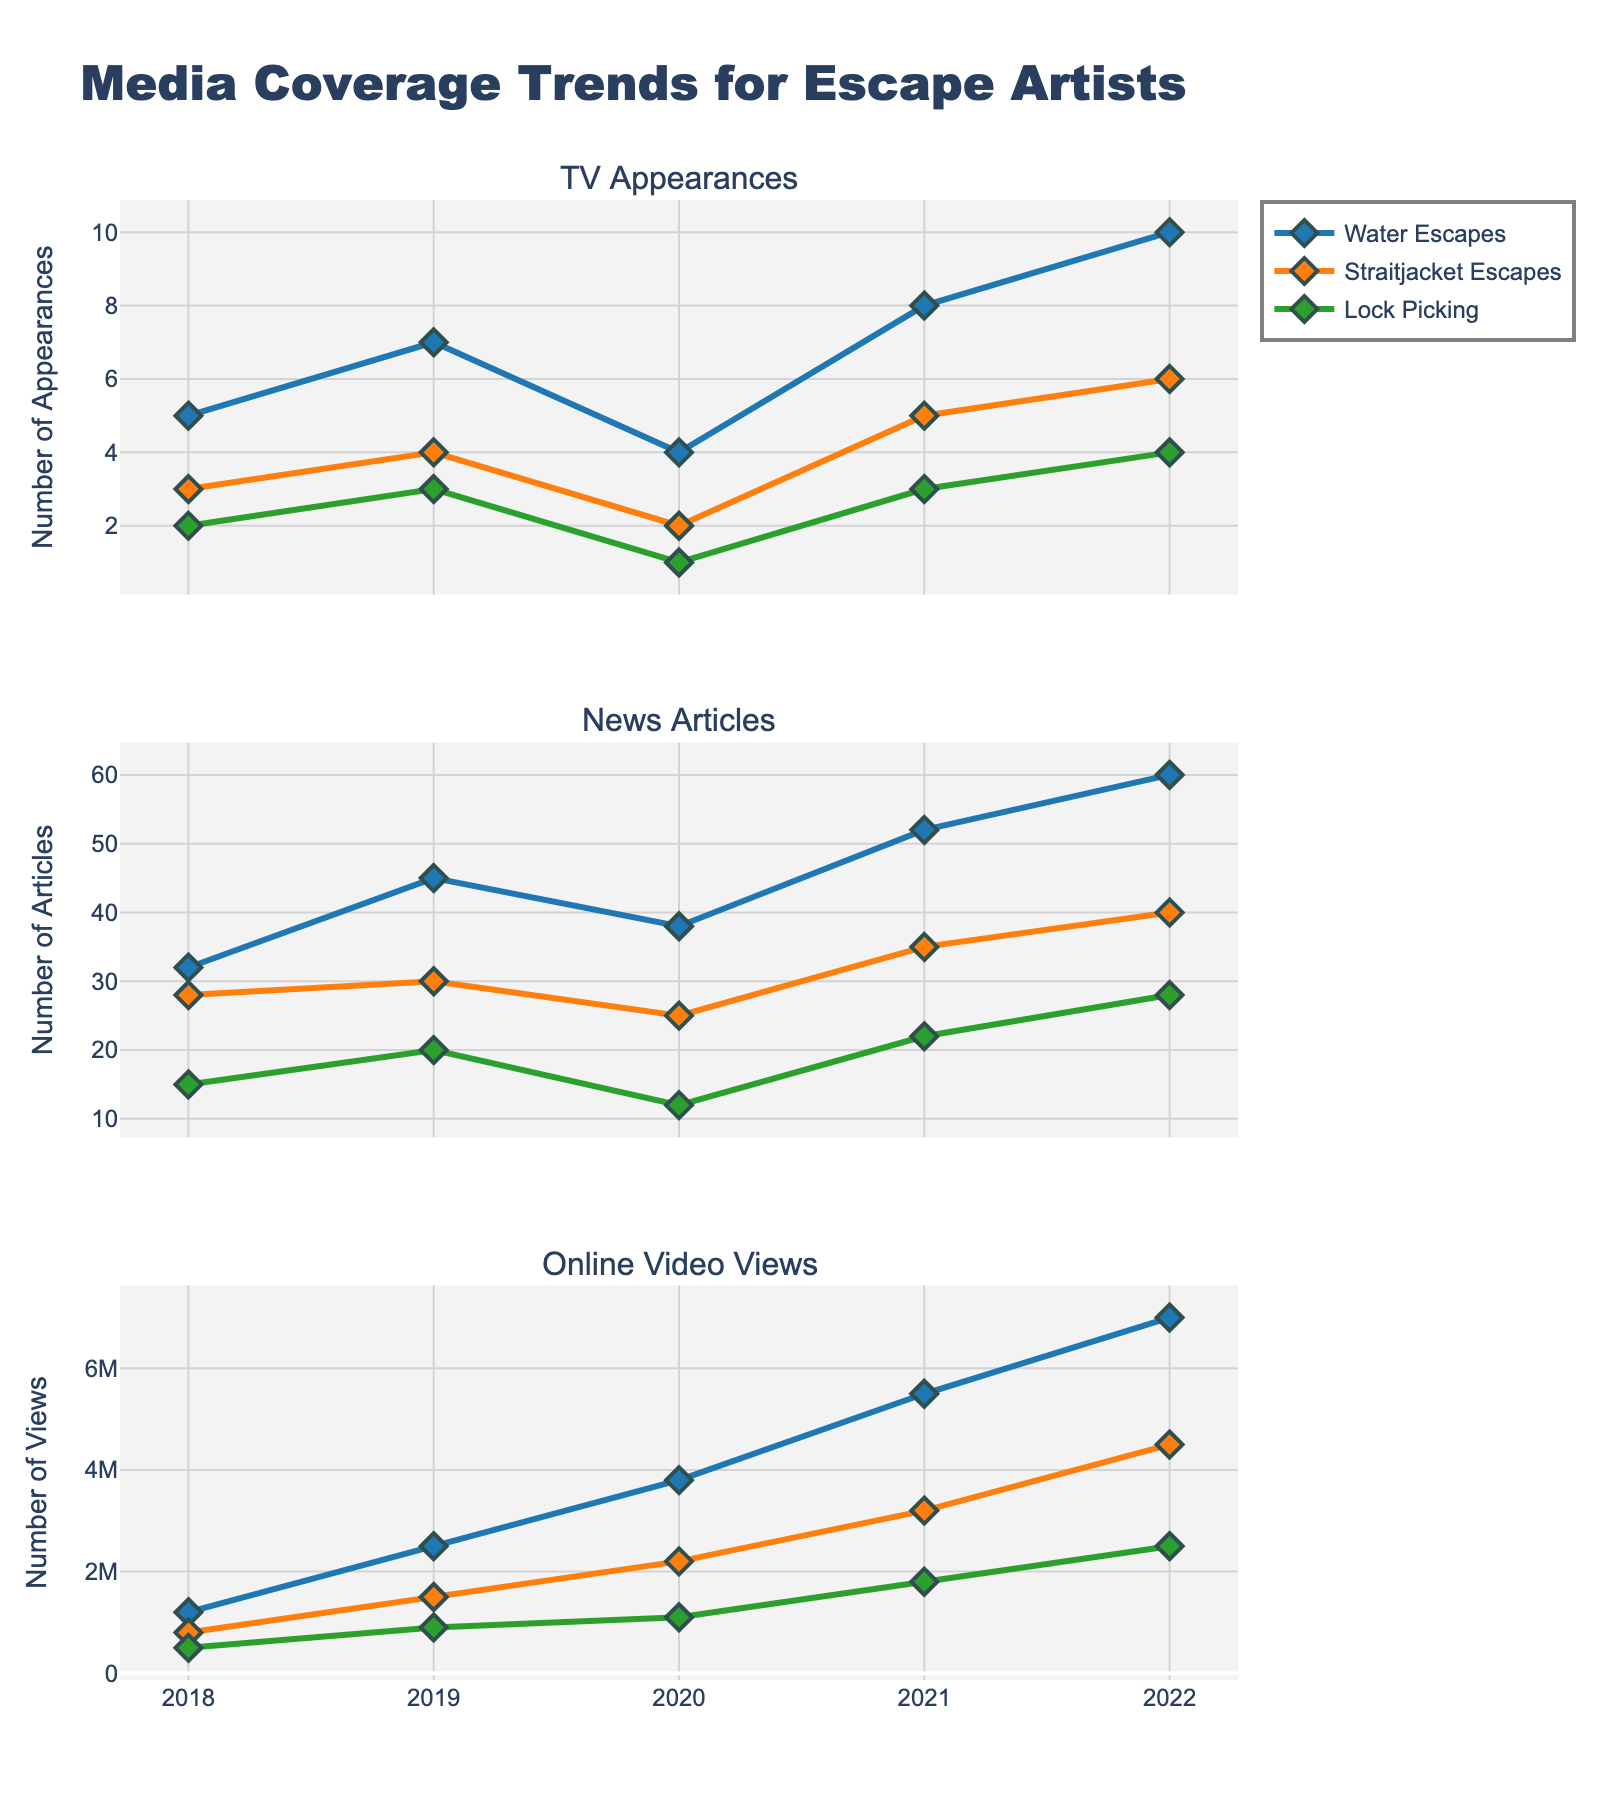Which performance type had the highest number of TV appearances in 2022? Looking at the "TV Appearances" subplot for 2022, Water Escapes recorded 10 appearances which is higher than any other performance types.
Answer: Water Escapes How many news articles were there in total for Straitjacket Escapes in the years 2019 and 2020 combined? Add the number of news articles for Straitjacket Escapes in 2019 (30) and 2020 (25). Thus, 30 + 25 = 55.
Answer: 55 Compare the trend of online video views for Lock Picking and Water Escapes from 2018 to 2022. Which performance type showed more growth? The online video views for Water Escapes in 2018 were 1,200,000 and grew to 7,000,000 in 2022, an increase of 5,800,000. Lock Picking started at 500,000 and rose to 2,500,000, an increase of 2,000,000. Water Escapes showed more growth.
Answer: Water Escapes In which year did TV Appearances for Water Escapes first surpass 5 appearances? Looking at the "TV Appearances" subplot, Water Escapes surpassed 5 appearances first in 2019 with 7 appearances.
Answer: 2019 What is the difference in the number of news articles between Water Escapes and Lock Picking in 2021? In 2021, Water Escapes had 52 news articles and Lock Picking had 22. The difference is 52 - 22 = 30.
Answer: 30 Which performance type had the least online video views in 2020 and what was the count? From the "Online Video Views" subplot for 2020, Lock Picking had the least views with 1,100,000.
Answer: Lock Picking, 1,100,000 What was the average number of TV Appearances for all performance types in 2018? Sum the TV Appearances for each type in 2018: 5 (Water Escapes) + 3 (Straitjacket Escapes) + 2 (Lock Picking) = 10. The number of types is 3, hence the average is 10 / 3 = 3.33 (rounded to two decimal places).
Answer: 3.33 Did the number of news articles about Straitjacket Escapes ever surpass the number of news articles about Water Escapes between 2018 and 2022? Comparing trends in the "News Articles" subplot, the number of articles for Straitjacket Escapes never surpassed that of Water Escapes in any year between 2018 and 2022.
Answer: No In which year did Straitjacket Escapes have the highest online video views and what was the count? Referring to the "Online Video Views" subplot, Straitjacket Escapes had the highest views in 2022 with 4,500,000 views.
Answer: 2022, 4,500,000 